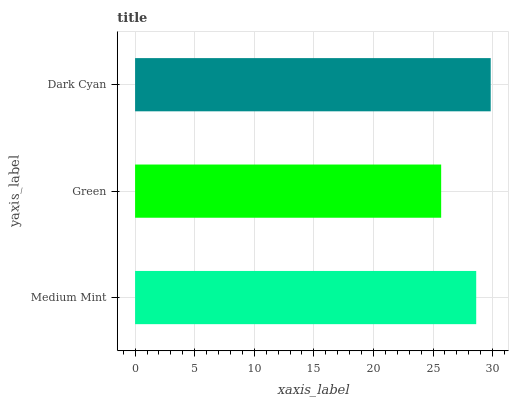Is Green the minimum?
Answer yes or no. Yes. Is Dark Cyan the maximum?
Answer yes or no. Yes. Is Dark Cyan the minimum?
Answer yes or no. No. Is Green the maximum?
Answer yes or no. No. Is Dark Cyan greater than Green?
Answer yes or no. Yes. Is Green less than Dark Cyan?
Answer yes or no. Yes. Is Green greater than Dark Cyan?
Answer yes or no. No. Is Dark Cyan less than Green?
Answer yes or no. No. Is Medium Mint the high median?
Answer yes or no. Yes. Is Medium Mint the low median?
Answer yes or no. Yes. Is Green the high median?
Answer yes or no. No. Is Dark Cyan the low median?
Answer yes or no. No. 